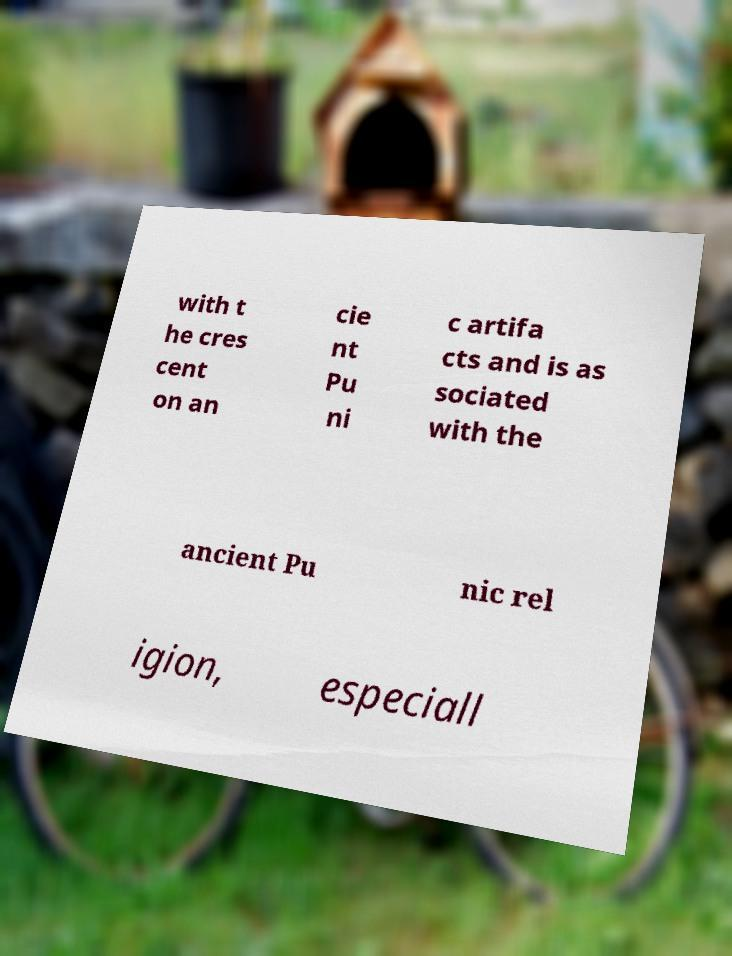Please identify and transcribe the text found in this image. with t he cres cent on an cie nt Pu ni c artifa cts and is as sociated with the ancient Pu nic rel igion, especiall 